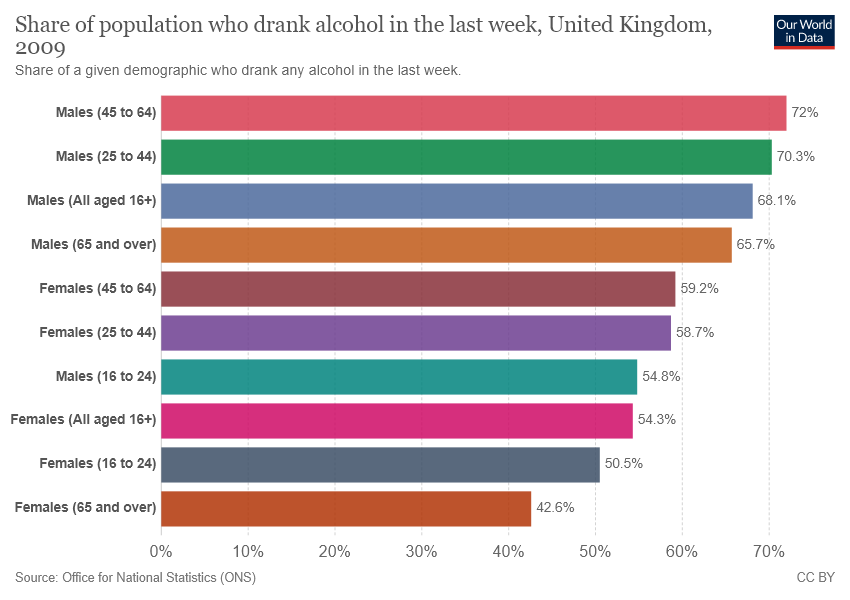Specify some key components in this picture. The average of the two smallest bars is approximately 0.4655. There are 10 categories in the chart. 